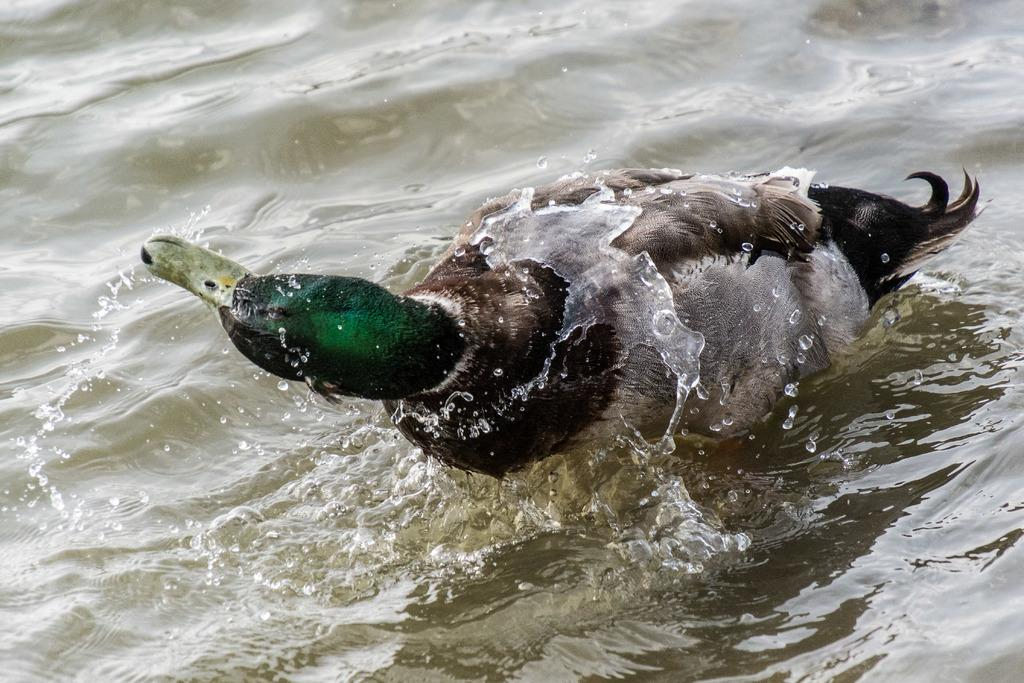What type of animal is in the image? There is a bird in the image. Can you identify the specific species of the bird? The bird is a mallard. What is the mallard doing in the image? The mallard is swimming in the water. How many chairs are visible in the image? There are no chairs present in the image; it features a mallard swimming in the water. Is the mallard being held in a jail in the image? No, the mallard is not being held in a jail in the image; it is swimming freely in the water. 